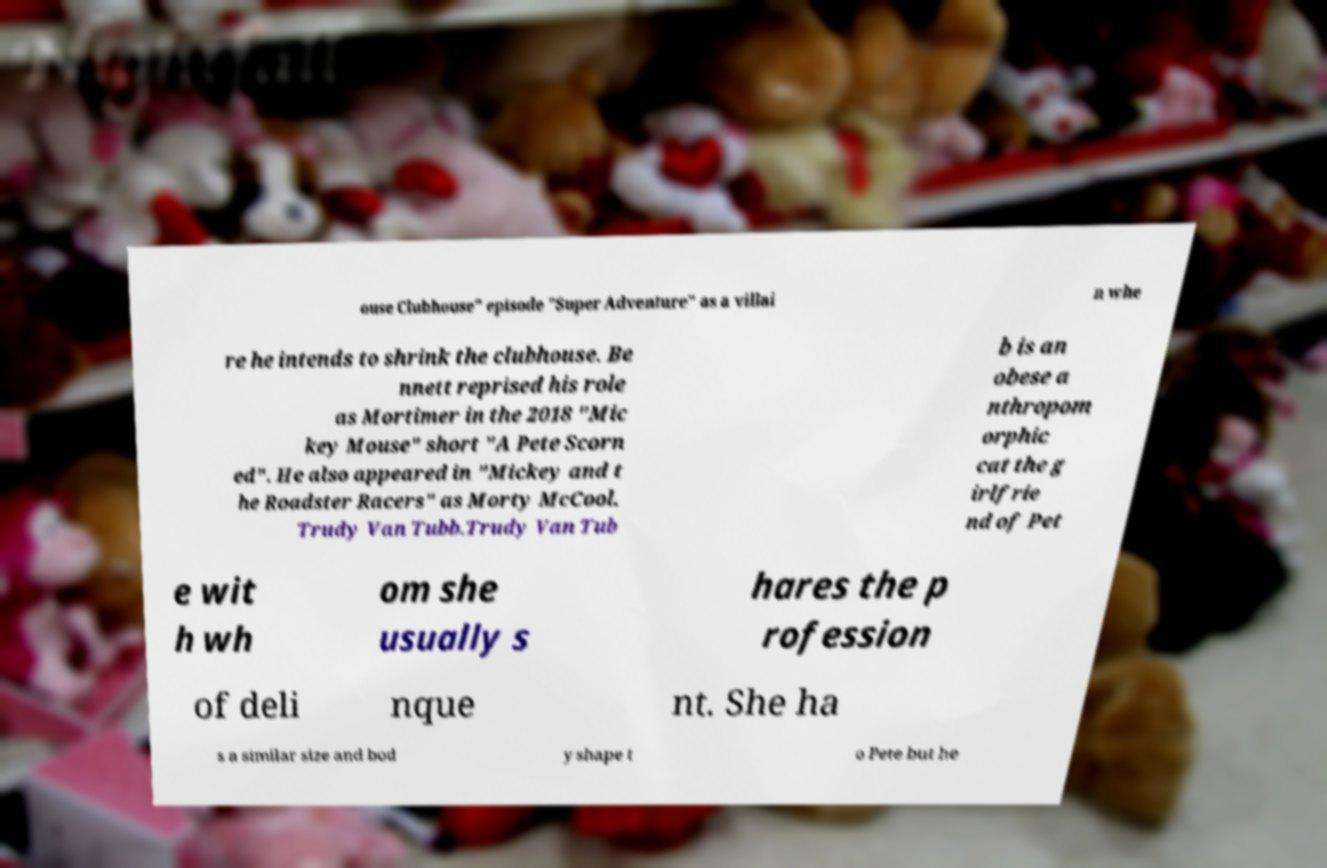I need the written content from this picture converted into text. Can you do that? ouse Clubhouse" episode "Super Adventure" as a villai n whe re he intends to shrink the clubhouse. Be nnett reprised his role as Mortimer in the 2018 "Mic key Mouse" short "A Pete Scorn ed". He also appeared in "Mickey and t he Roadster Racers" as Morty McCool. Trudy Van Tubb.Trudy Van Tub b is an obese a nthropom orphic cat the g irlfrie nd of Pet e wit h wh om she usually s hares the p rofession of deli nque nt. She ha s a similar size and bod y shape t o Pete but he 